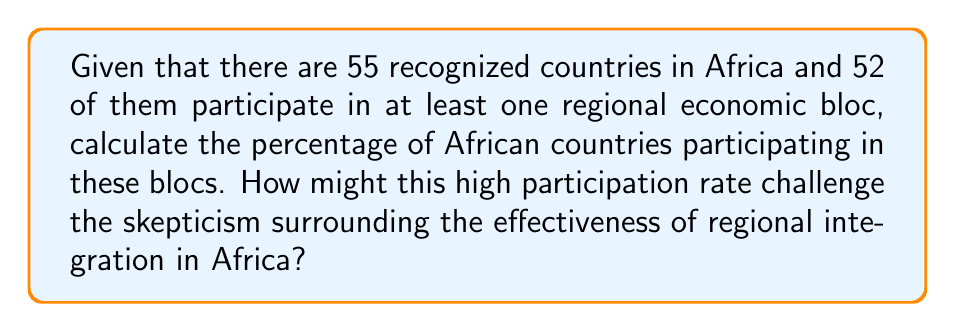What is the answer to this math problem? To calculate the percentage of African countries participating in regional economic blocs, we need to follow these steps:

1. Identify the total number of countries: 55
2. Identify the number of participating countries: 52
3. Calculate the percentage using the formula:

$$ \text{Percentage} = \frac{\text{Number of participating countries}}{\text{Total number of countries}} \times 100\% $$

Let's plug in the numbers:

$$ \text{Percentage} = \frac{52}{55} \times 100\% $$

To simplify this fraction, we can divide both numerator and denominator by their greatest common divisor (GCD), which is 1:

$$ \text{Percentage} = \frac{52}{55} \times 100\% $$

Now, let's perform the division:

$$ \frac{52}{55} \approx 0.9454545454545455 $$

Multiplying by 100% to get the percentage:

$$ 0.9454545454545455 \times 100\% \approx 94.55\% $$

This high participation rate of approximately 94.55% challenges skepticism about regional integration effectiveness by showing that almost all African countries are engaged in these economic blocs, suggesting widespread recognition of their potential benefits.
Answer: 94.55% 